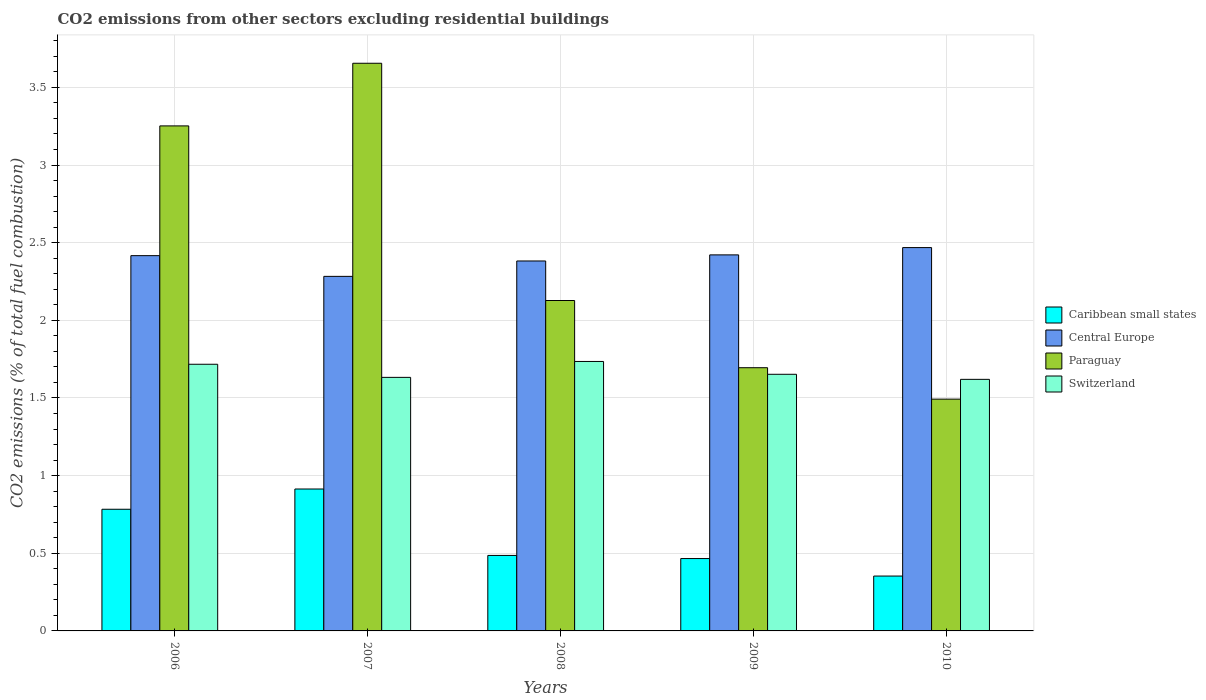Are the number of bars per tick equal to the number of legend labels?
Your answer should be compact. Yes. Are the number of bars on each tick of the X-axis equal?
Give a very brief answer. Yes. How many bars are there on the 2nd tick from the left?
Keep it short and to the point. 4. What is the label of the 4th group of bars from the left?
Your answer should be very brief. 2009. What is the total CO2 emitted in Caribbean small states in 2007?
Your answer should be compact. 0.91. Across all years, what is the maximum total CO2 emitted in Central Europe?
Keep it short and to the point. 2.47. Across all years, what is the minimum total CO2 emitted in Caribbean small states?
Your response must be concise. 0.35. In which year was the total CO2 emitted in Switzerland maximum?
Provide a succinct answer. 2008. What is the total total CO2 emitted in Paraguay in the graph?
Provide a succinct answer. 12.22. What is the difference between the total CO2 emitted in Paraguay in 2006 and that in 2008?
Provide a short and direct response. 1.12. What is the difference between the total CO2 emitted in Caribbean small states in 2010 and the total CO2 emitted in Paraguay in 2006?
Keep it short and to the point. -2.9. What is the average total CO2 emitted in Caribbean small states per year?
Offer a terse response. 0.6. In the year 2008, what is the difference between the total CO2 emitted in Paraguay and total CO2 emitted in Central Europe?
Ensure brevity in your answer.  -0.25. What is the ratio of the total CO2 emitted in Switzerland in 2006 to that in 2008?
Provide a short and direct response. 0.99. Is the difference between the total CO2 emitted in Paraguay in 2006 and 2009 greater than the difference between the total CO2 emitted in Central Europe in 2006 and 2009?
Your answer should be very brief. Yes. What is the difference between the highest and the second highest total CO2 emitted in Caribbean small states?
Make the answer very short. 0.13. What is the difference between the highest and the lowest total CO2 emitted in Switzerland?
Make the answer very short. 0.12. In how many years, is the total CO2 emitted in Caribbean small states greater than the average total CO2 emitted in Caribbean small states taken over all years?
Offer a very short reply. 2. Is the sum of the total CO2 emitted in Caribbean small states in 2009 and 2010 greater than the maximum total CO2 emitted in Central Europe across all years?
Provide a succinct answer. No. Is it the case that in every year, the sum of the total CO2 emitted in Paraguay and total CO2 emitted in Central Europe is greater than the sum of total CO2 emitted in Switzerland and total CO2 emitted in Caribbean small states?
Your response must be concise. No. What does the 1st bar from the left in 2007 represents?
Your answer should be very brief. Caribbean small states. What does the 1st bar from the right in 2008 represents?
Your response must be concise. Switzerland. Is it the case that in every year, the sum of the total CO2 emitted in Switzerland and total CO2 emitted in Paraguay is greater than the total CO2 emitted in Caribbean small states?
Offer a terse response. Yes. Are all the bars in the graph horizontal?
Give a very brief answer. No. Are the values on the major ticks of Y-axis written in scientific E-notation?
Your answer should be compact. No. Does the graph contain any zero values?
Your answer should be very brief. No. Does the graph contain grids?
Your answer should be very brief. Yes. Where does the legend appear in the graph?
Give a very brief answer. Center right. How many legend labels are there?
Offer a terse response. 4. How are the legend labels stacked?
Offer a terse response. Vertical. What is the title of the graph?
Offer a very short reply. CO2 emissions from other sectors excluding residential buildings. What is the label or title of the X-axis?
Make the answer very short. Years. What is the label or title of the Y-axis?
Make the answer very short. CO2 emissions (% of total fuel combustion). What is the CO2 emissions (% of total fuel combustion) in Caribbean small states in 2006?
Make the answer very short. 0.78. What is the CO2 emissions (% of total fuel combustion) in Central Europe in 2006?
Make the answer very short. 2.42. What is the CO2 emissions (% of total fuel combustion) of Paraguay in 2006?
Your answer should be compact. 3.25. What is the CO2 emissions (% of total fuel combustion) of Switzerland in 2006?
Provide a short and direct response. 1.72. What is the CO2 emissions (% of total fuel combustion) in Caribbean small states in 2007?
Provide a succinct answer. 0.91. What is the CO2 emissions (% of total fuel combustion) in Central Europe in 2007?
Provide a succinct answer. 2.28. What is the CO2 emissions (% of total fuel combustion) of Paraguay in 2007?
Provide a short and direct response. 3.66. What is the CO2 emissions (% of total fuel combustion) in Switzerland in 2007?
Keep it short and to the point. 1.63. What is the CO2 emissions (% of total fuel combustion) of Caribbean small states in 2008?
Your response must be concise. 0.49. What is the CO2 emissions (% of total fuel combustion) of Central Europe in 2008?
Offer a terse response. 2.38. What is the CO2 emissions (% of total fuel combustion) in Paraguay in 2008?
Ensure brevity in your answer.  2.13. What is the CO2 emissions (% of total fuel combustion) in Switzerland in 2008?
Give a very brief answer. 1.74. What is the CO2 emissions (% of total fuel combustion) in Caribbean small states in 2009?
Provide a succinct answer. 0.47. What is the CO2 emissions (% of total fuel combustion) of Central Europe in 2009?
Keep it short and to the point. 2.42. What is the CO2 emissions (% of total fuel combustion) in Paraguay in 2009?
Provide a short and direct response. 1.69. What is the CO2 emissions (% of total fuel combustion) of Switzerland in 2009?
Keep it short and to the point. 1.65. What is the CO2 emissions (% of total fuel combustion) in Caribbean small states in 2010?
Give a very brief answer. 0.35. What is the CO2 emissions (% of total fuel combustion) in Central Europe in 2010?
Offer a terse response. 2.47. What is the CO2 emissions (% of total fuel combustion) in Paraguay in 2010?
Give a very brief answer. 1.49. What is the CO2 emissions (% of total fuel combustion) in Switzerland in 2010?
Make the answer very short. 1.62. Across all years, what is the maximum CO2 emissions (% of total fuel combustion) in Caribbean small states?
Offer a very short reply. 0.91. Across all years, what is the maximum CO2 emissions (% of total fuel combustion) in Central Europe?
Your response must be concise. 2.47. Across all years, what is the maximum CO2 emissions (% of total fuel combustion) of Paraguay?
Offer a terse response. 3.66. Across all years, what is the maximum CO2 emissions (% of total fuel combustion) of Switzerland?
Keep it short and to the point. 1.74. Across all years, what is the minimum CO2 emissions (% of total fuel combustion) in Caribbean small states?
Make the answer very short. 0.35. Across all years, what is the minimum CO2 emissions (% of total fuel combustion) in Central Europe?
Offer a terse response. 2.28. Across all years, what is the minimum CO2 emissions (% of total fuel combustion) of Paraguay?
Offer a terse response. 1.49. Across all years, what is the minimum CO2 emissions (% of total fuel combustion) in Switzerland?
Your answer should be compact. 1.62. What is the total CO2 emissions (% of total fuel combustion) in Caribbean small states in the graph?
Offer a very short reply. 3. What is the total CO2 emissions (% of total fuel combustion) of Central Europe in the graph?
Your response must be concise. 11.97. What is the total CO2 emissions (% of total fuel combustion) in Paraguay in the graph?
Your answer should be very brief. 12.22. What is the total CO2 emissions (% of total fuel combustion) of Switzerland in the graph?
Offer a very short reply. 8.36. What is the difference between the CO2 emissions (% of total fuel combustion) of Caribbean small states in 2006 and that in 2007?
Offer a terse response. -0.13. What is the difference between the CO2 emissions (% of total fuel combustion) in Central Europe in 2006 and that in 2007?
Offer a very short reply. 0.13. What is the difference between the CO2 emissions (% of total fuel combustion) in Paraguay in 2006 and that in 2007?
Offer a very short reply. -0.4. What is the difference between the CO2 emissions (% of total fuel combustion) in Switzerland in 2006 and that in 2007?
Offer a terse response. 0.08. What is the difference between the CO2 emissions (% of total fuel combustion) of Caribbean small states in 2006 and that in 2008?
Your answer should be compact. 0.3. What is the difference between the CO2 emissions (% of total fuel combustion) of Central Europe in 2006 and that in 2008?
Provide a succinct answer. 0.03. What is the difference between the CO2 emissions (% of total fuel combustion) of Paraguay in 2006 and that in 2008?
Your answer should be very brief. 1.12. What is the difference between the CO2 emissions (% of total fuel combustion) of Switzerland in 2006 and that in 2008?
Your answer should be compact. -0.02. What is the difference between the CO2 emissions (% of total fuel combustion) of Caribbean small states in 2006 and that in 2009?
Your answer should be compact. 0.32. What is the difference between the CO2 emissions (% of total fuel combustion) of Central Europe in 2006 and that in 2009?
Give a very brief answer. -0. What is the difference between the CO2 emissions (% of total fuel combustion) of Paraguay in 2006 and that in 2009?
Provide a succinct answer. 1.56. What is the difference between the CO2 emissions (% of total fuel combustion) of Switzerland in 2006 and that in 2009?
Give a very brief answer. 0.06. What is the difference between the CO2 emissions (% of total fuel combustion) in Caribbean small states in 2006 and that in 2010?
Your response must be concise. 0.43. What is the difference between the CO2 emissions (% of total fuel combustion) in Central Europe in 2006 and that in 2010?
Your answer should be compact. -0.05. What is the difference between the CO2 emissions (% of total fuel combustion) in Paraguay in 2006 and that in 2010?
Ensure brevity in your answer.  1.76. What is the difference between the CO2 emissions (% of total fuel combustion) in Switzerland in 2006 and that in 2010?
Your answer should be very brief. 0.1. What is the difference between the CO2 emissions (% of total fuel combustion) in Caribbean small states in 2007 and that in 2008?
Your answer should be very brief. 0.43. What is the difference between the CO2 emissions (% of total fuel combustion) in Central Europe in 2007 and that in 2008?
Offer a very short reply. -0.1. What is the difference between the CO2 emissions (% of total fuel combustion) in Paraguay in 2007 and that in 2008?
Provide a succinct answer. 1.53. What is the difference between the CO2 emissions (% of total fuel combustion) in Switzerland in 2007 and that in 2008?
Make the answer very short. -0.1. What is the difference between the CO2 emissions (% of total fuel combustion) in Caribbean small states in 2007 and that in 2009?
Your answer should be compact. 0.45. What is the difference between the CO2 emissions (% of total fuel combustion) of Central Europe in 2007 and that in 2009?
Offer a terse response. -0.14. What is the difference between the CO2 emissions (% of total fuel combustion) of Paraguay in 2007 and that in 2009?
Ensure brevity in your answer.  1.96. What is the difference between the CO2 emissions (% of total fuel combustion) of Switzerland in 2007 and that in 2009?
Your answer should be compact. -0.02. What is the difference between the CO2 emissions (% of total fuel combustion) in Caribbean small states in 2007 and that in 2010?
Your answer should be compact. 0.56. What is the difference between the CO2 emissions (% of total fuel combustion) of Central Europe in 2007 and that in 2010?
Your response must be concise. -0.19. What is the difference between the CO2 emissions (% of total fuel combustion) in Paraguay in 2007 and that in 2010?
Your answer should be very brief. 2.16. What is the difference between the CO2 emissions (% of total fuel combustion) in Switzerland in 2007 and that in 2010?
Make the answer very short. 0.01. What is the difference between the CO2 emissions (% of total fuel combustion) in Caribbean small states in 2008 and that in 2009?
Give a very brief answer. 0.02. What is the difference between the CO2 emissions (% of total fuel combustion) of Central Europe in 2008 and that in 2009?
Give a very brief answer. -0.04. What is the difference between the CO2 emissions (% of total fuel combustion) in Paraguay in 2008 and that in 2009?
Ensure brevity in your answer.  0.43. What is the difference between the CO2 emissions (% of total fuel combustion) in Switzerland in 2008 and that in 2009?
Give a very brief answer. 0.08. What is the difference between the CO2 emissions (% of total fuel combustion) in Caribbean small states in 2008 and that in 2010?
Make the answer very short. 0.13. What is the difference between the CO2 emissions (% of total fuel combustion) in Central Europe in 2008 and that in 2010?
Give a very brief answer. -0.09. What is the difference between the CO2 emissions (% of total fuel combustion) in Paraguay in 2008 and that in 2010?
Your answer should be very brief. 0.64. What is the difference between the CO2 emissions (% of total fuel combustion) of Switzerland in 2008 and that in 2010?
Ensure brevity in your answer.  0.12. What is the difference between the CO2 emissions (% of total fuel combustion) of Caribbean small states in 2009 and that in 2010?
Your answer should be compact. 0.11. What is the difference between the CO2 emissions (% of total fuel combustion) in Central Europe in 2009 and that in 2010?
Provide a succinct answer. -0.05. What is the difference between the CO2 emissions (% of total fuel combustion) in Paraguay in 2009 and that in 2010?
Offer a very short reply. 0.2. What is the difference between the CO2 emissions (% of total fuel combustion) in Switzerland in 2009 and that in 2010?
Your response must be concise. 0.03. What is the difference between the CO2 emissions (% of total fuel combustion) in Caribbean small states in 2006 and the CO2 emissions (% of total fuel combustion) in Central Europe in 2007?
Provide a short and direct response. -1.5. What is the difference between the CO2 emissions (% of total fuel combustion) of Caribbean small states in 2006 and the CO2 emissions (% of total fuel combustion) of Paraguay in 2007?
Your answer should be very brief. -2.87. What is the difference between the CO2 emissions (% of total fuel combustion) in Caribbean small states in 2006 and the CO2 emissions (% of total fuel combustion) in Switzerland in 2007?
Give a very brief answer. -0.85. What is the difference between the CO2 emissions (% of total fuel combustion) in Central Europe in 2006 and the CO2 emissions (% of total fuel combustion) in Paraguay in 2007?
Ensure brevity in your answer.  -1.24. What is the difference between the CO2 emissions (% of total fuel combustion) in Central Europe in 2006 and the CO2 emissions (% of total fuel combustion) in Switzerland in 2007?
Provide a succinct answer. 0.78. What is the difference between the CO2 emissions (% of total fuel combustion) in Paraguay in 2006 and the CO2 emissions (% of total fuel combustion) in Switzerland in 2007?
Ensure brevity in your answer.  1.62. What is the difference between the CO2 emissions (% of total fuel combustion) in Caribbean small states in 2006 and the CO2 emissions (% of total fuel combustion) in Central Europe in 2008?
Your answer should be compact. -1.6. What is the difference between the CO2 emissions (% of total fuel combustion) of Caribbean small states in 2006 and the CO2 emissions (% of total fuel combustion) of Paraguay in 2008?
Offer a terse response. -1.34. What is the difference between the CO2 emissions (% of total fuel combustion) in Caribbean small states in 2006 and the CO2 emissions (% of total fuel combustion) in Switzerland in 2008?
Your answer should be very brief. -0.95. What is the difference between the CO2 emissions (% of total fuel combustion) of Central Europe in 2006 and the CO2 emissions (% of total fuel combustion) of Paraguay in 2008?
Offer a very short reply. 0.29. What is the difference between the CO2 emissions (% of total fuel combustion) in Central Europe in 2006 and the CO2 emissions (% of total fuel combustion) in Switzerland in 2008?
Your answer should be compact. 0.68. What is the difference between the CO2 emissions (% of total fuel combustion) in Paraguay in 2006 and the CO2 emissions (% of total fuel combustion) in Switzerland in 2008?
Provide a short and direct response. 1.52. What is the difference between the CO2 emissions (% of total fuel combustion) of Caribbean small states in 2006 and the CO2 emissions (% of total fuel combustion) of Central Europe in 2009?
Your response must be concise. -1.64. What is the difference between the CO2 emissions (% of total fuel combustion) in Caribbean small states in 2006 and the CO2 emissions (% of total fuel combustion) in Paraguay in 2009?
Give a very brief answer. -0.91. What is the difference between the CO2 emissions (% of total fuel combustion) of Caribbean small states in 2006 and the CO2 emissions (% of total fuel combustion) of Switzerland in 2009?
Ensure brevity in your answer.  -0.87. What is the difference between the CO2 emissions (% of total fuel combustion) in Central Europe in 2006 and the CO2 emissions (% of total fuel combustion) in Paraguay in 2009?
Your response must be concise. 0.72. What is the difference between the CO2 emissions (% of total fuel combustion) in Central Europe in 2006 and the CO2 emissions (% of total fuel combustion) in Switzerland in 2009?
Your answer should be very brief. 0.76. What is the difference between the CO2 emissions (% of total fuel combustion) of Paraguay in 2006 and the CO2 emissions (% of total fuel combustion) of Switzerland in 2009?
Keep it short and to the point. 1.6. What is the difference between the CO2 emissions (% of total fuel combustion) in Caribbean small states in 2006 and the CO2 emissions (% of total fuel combustion) in Central Europe in 2010?
Your answer should be very brief. -1.68. What is the difference between the CO2 emissions (% of total fuel combustion) of Caribbean small states in 2006 and the CO2 emissions (% of total fuel combustion) of Paraguay in 2010?
Ensure brevity in your answer.  -0.71. What is the difference between the CO2 emissions (% of total fuel combustion) of Caribbean small states in 2006 and the CO2 emissions (% of total fuel combustion) of Switzerland in 2010?
Offer a very short reply. -0.84. What is the difference between the CO2 emissions (% of total fuel combustion) of Central Europe in 2006 and the CO2 emissions (% of total fuel combustion) of Paraguay in 2010?
Give a very brief answer. 0.92. What is the difference between the CO2 emissions (% of total fuel combustion) in Central Europe in 2006 and the CO2 emissions (% of total fuel combustion) in Switzerland in 2010?
Make the answer very short. 0.8. What is the difference between the CO2 emissions (% of total fuel combustion) of Paraguay in 2006 and the CO2 emissions (% of total fuel combustion) of Switzerland in 2010?
Make the answer very short. 1.63. What is the difference between the CO2 emissions (% of total fuel combustion) of Caribbean small states in 2007 and the CO2 emissions (% of total fuel combustion) of Central Europe in 2008?
Keep it short and to the point. -1.47. What is the difference between the CO2 emissions (% of total fuel combustion) in Caribbean small states in 2007 and the CO2 emissions (% of total fuel combustion) in Paraguay in 2008?
Offer a very short reply. -1.21. What is the difference between the CO2 emissions (% of total fuel combustion) in Caribbean small states in 2007 and the CO2 emissions (% of total fuel combustion) in Switzerland in 2008?
Provide a short and direct response. -0.82. What is the difference between the CO2 emissions (% of total fuel combustion) of Central Europe in 2007 and the CO2 emissions (% of total fuel combustion) of Paraguay in 2008?
Provide a short and direct response. 0.16. What is the difference between the CO2 emissions (% of total fuel combustion) of Central Europe in 2007 and the CO2 emissions (% of total fuel combustion) of Switzerland in 2008?
Provide a short and direct response. 0.55. What is the difference between the CO2 emissions (% of total fuel combustion) in Paraguay in 2007 and the CO2 emissions (% of total fuel combustion) in Switzerland in 2008?
Your answer should be very brief. 1.92. What is the difference between the CO2 emissions (% of total fuel combustion) in Caribbean small states in 2007 and the CO2 emissions (% of total fuel combustion) in Central Europe in 2009?
Provide a succinct answer. -1.51. What is the difference between the CO2 emissions (% of total fuel combustion) in Caribbean small states in 2007 and the CO2 emissions (% of total fuel combustion) in Paraguay in 2009?
Provide a short and direct response. -0.78. What is the difference between the CO2 emissions (% of total fuel combustion) of Caribbean small states in 2007 and the CO2 emissions (% of total fuel combustion) of Switzerland in 2009?
Provide a succinct answer. -0.74. What is the difference between the CO2 emissions (% of total fuel combustion) of Central Europe in 2007 and the CO2 emissions (% of total fuel combustion) of Paraguay in 2009?
Offer a terse response. 0.59. What is the difference between the CO2 emissions (% of total fuel combustion) in Central Europe in 2007 and the CO2 emissions (% of total fuel combustion) in Switzerland in 2009?
Your answer should be compact. 0.63. What is the difference between the CO2 emissions (% of total fuel combustion) in Paraguay in 2007 and the CO2 emissions (% of total fuel combustion) in Switzerland in 2009?
Offer a very short reply. 2. What is the difference between the CO2 emissions (% of total fuel combustion) of Caribbean small states in 2007 and the CO2 emissions (% of total fuel combustion) of Central Europe in 2010?
Your answer should be very brief. -1.55. What is the difference between the CO2 emissions (% of total fuel combustion) of Caribbean small states in 2007 and the CO2 emissions (% of total fuel combustion) of Paraguay in 2010?
Keep it short and to the point. -0.58. What is the difference between the CO2 emissions (% of total fuel combustion) of Caribbean small states in 2007 and the CO2 emissions (% of total fuel combustion) of Switzerland in 2010?
Make the answer very short. -0.71. What is the difference between the CO2 emissions (% of total fuel combustion) of Central Europe in 2007 and the CO2 emissions (% of total fuel combustion) of Paraguay in 2010?
Keep it short and to the point. 0.79. What is the difference between the CO2 emissions (% of total fuel combustion) in Central Europe in 2007 and the CO2 emissions (% of total fuel combustion) in Switzerland in 2010?
Your answer should be very brief. 0.66. What is the difference between the CO2 emissions (% of total fuel combustion) in Paraguay in 2007 and the CO2 emissions (% of total fuel combustion) in Switzerland in 2010?
Keep it short and to the point. 2.04. What is the difference between the CO2 emissions (% of total fuel combustion) of Caribbean small states in 2008 and the CO2 emissions (% of total fuel combustion) of Central Europe in 2009?
Offer a very short reply. -1.94. What is the difference between the CO2 emissions (% of total fuel combustion) in Caribbean small states in 2008 and the CO2 emissions (% of total fuel combustion) in Paraguay in 2009?
Give a very brief answer. -1.21. What is the difference between the CO2 emissions (% of total fuel combustion) in Caribbean small states in 2008 and the CO2 emissions (% of total fuel combustion) in Switzerland in 2009?
Offer a terse response. -1.17. What is the difference between the CO2 emissions (% of total fuel combustion) of Central Europe in 2008 and the CO2 emissions (% of total fuel combustion) of Paraguay in 2009?
Provide a succinct answer. 0.69. What is the difference between the CO2 emissions (% of total fuel combustion) in Central Europe in 2008 and the CO2 emissions (% of total fuel combustion) in Switzerland in 2009?
Ensure brevity in your answer.  0.73. What is the difference between the CO2 emissions (% of total fuel combustion) of Paraguay in 2008 and the CO2 emissions (% of total fuel combustion) of Switzerland in 2009?
Your answer should be very brief. 0.48. What is the difference between the CO2 emissions (% of total fuel combustion) in Caribbean small states in 2008 and the CO2 emissions (% of total fuel combustion) in Central Europe in 2010?
Ensure brevity in your answer.  -1.98. What is the difference between the CO2 emissions (% of total fuel combustion) in Caribbean small states in 2008 and the CO2 emissions (% of total fuel combustion) in Paraguay in 2010?
Make the answer very short. -1.01. What is the difference between the CO2 emissions (% of total fuel combustion) in Caribbean small states in 2008 and the CO2 emissions (% of total fuel combustion) in Switzerland in 2010?
Keep it short and to the point. -1.13. What is the difference between the CO2 emissions (% of total fuel combustion) in Central Europe in 2008 and the CO2 emissions (% of total fuel combustion) in Paraguay in 2010?
Your answer should be very brief. 0.89. What is the difference between the CO2 emissions (% of total fuel combustion) of Central Europe in 2008 and the CO2 emissions (% of total fuel combustion) of Switzerland in 2010?
Make the answer very short. 0.76. What is the difference between the CO2 emissions (% of total fuel combustion) in Paraguay in 2008 and the CO2 emissions (% of total fuel combustion) in Switzerland in 2010?
Offer a terse response. 0.51. What is the difference between the CO2 emissions (% of total fuel combustion) in Caribbean small states in 2009 and the CO2 emissions (% of total fuel combustion) in Central Europe in 2010?
Your response must be concise. -2. What is the difference between the CO2 emissions (% of total fuel combustion) of Caribbean small states in 2009 and the CO2 emissions (% of total fuel combustion) of Paraguay in 2010?
Your answer should be compact. -1.03. What is the difference between the CO2 emissions (% of total fuel combustion) of Caribbean small states in 2009 and the CO2 emissions (% of total fuel combustion) of Switzerland in 2010?
Keep it short and to the point. -1.15. What is the difference between the CO2 emissions (% of total fuel combustion) in Central Europe in 2009 and the CO2 emissions (% of total fuel combustion) in Paraguay in 2010?
Provide a succinct answer. 0.93. What is the difference between the CO2 emissions (% of total fuel combustion) in Central Europe in 2009 and the CO2 emissions (% of total fuel combustion) in Switzerland in 2010?
Offer a very short reply. 0.8. What is the difference between the CO2 emissions (% of total fuel combustion) of Paraguay in 2009 and the CO2 emissions (% of total fuel combustion) of Switzerland in 2010?
Offer a very short reply. 0.07. What is the average CO2 emissions (% of total fuel combustion) in Caribbean small states per year?
Give a very brief answer. 0.6. What is the average CO2 emissions (% of total fuel combustion) of Central Europe per year?
Your answer should be very brief. 2.39. What is the average CO2 emissions (% of total fuel combustion) of Paraguay per year?
Offer a terse response. 2.44. What is the average CO2 emissions (% of total fuel combustion) in Switzerland per year?
Provide a succinct answer. 1.67. In the year 2006, what is the difference between the CO2 emissions (% of total fuel combustion) of Caribbean small states and CO2 emissions (% of total fuel combustion) of Central Europe?
Give a very brief answer. -1.63. In the year 2006, what is the difference between the CO2 emissions (% of total fuel combustion) in Caribbean small states and CO2 emissions (% of total fuel combustion) in Paraguay?
Your answer should be very brief. -2.47. In the year 2006, what is the difference between the CO2 emissions (% of total fuel combustion) of Caribbean small states and CO2 emissions (% of total fuel combustion) of Switzerland?
Provide a short and direct response. -0.93. In the year 2006, what is the difference between the CO2 emissions (% of total fuel combustion) of Central Europe and CO2 emissions (% of total fuel combustion) of Paraguay?
Your answer should be compact. -0.84. In the year 2006, what is the difference between the CO2 emissions (% of total fuel combustion) in Central Europe and CO2 emissions (% of total fuel combustion) in Switzerland?
Provide a short and direct response. 0.7. In the year 2006, what is the difference between the CO2 emissions (% of total fuel combustion) in Paraguay and CO2 emissions (% of total fuel combustion) in Switzerland?
Your answer should be very brief. 1.53. In the year 2007, what is the difference between the CO2 emissions (% of total fuel combustion) of Caribbean small states and CO2 emissions (% of total fuel combustion) of Central Europe?
Ensure brevity in your answer.  -1.37. In the year 2007, what is the difference between the CO2 emissions (% of total fuel combustion) of Caribbean small states and CO2 emissions (% of total fuel combustion) of Paraguay?
Give a very brief answer. -2.74. In the year 2007, what is the difference between the CO2 emissions (% of total fuel combustion) in Caribbean small states and CO2 emissions (% of total fuel combustion) in Switzerland?
Your answer should be very brief. -0.72. In the year 2007, what is the difference between the CO2 emissions (% of total fuel combustion) in Central Europe and CO2 emissions (% of total fuel combustion) in Paraguay?
Provide a succinct answer. -1.37. In the year 2007, what is the difference between the CO2 emissions (% of total fuel combustion) in Central Europe and CO2 emissions (% of total fuel combustion) in Switzerland?
Offer a very short reply. 0.65. In the year 2007, what is the difference between the CO2 emissions (% of total fuel combustion) of Paraguay and CO2 emissions (% of total fuel combustion) of Switzerland?
Offer a very short reply. 2.02. In the year 2008, what is the difference between the CO2 emissions (% of total fuel combustion) of Caribbean small states and CO2 emissions (% of total fuel combustion) of Central Europe?
Provide a short and direct response. -1.9. In the year 2008, what is the difference between the CO2 emissions (% of total fuel combustion) in Caribbean small states and CO2 emissions (% of total fuel combustion) in Paraguay?
Keep it short and to the point. -1.64. In the year 2008, what is the difference between the CO2 emissions (% of total fuel combustion) in Caribbean small states and CO2 emissions (% of total fuel combustion) in Switzerland?
Offer a very short reply. -1.25. In the year 2008, what is the difference between the CO2 emissions (% of total fuel combustion) in Central Europe and CO2 emissions (% of total fuel combustion) in Paraguay?
Provide a succinct answer. 0.25. In the year 2008, what is the difference between the CO2 emissions (% of total fuel combustion) in Central Europe and CO2 emissions (% of total fuel combustion) in Switzerland?
Ensure brevity in your answer.  0.65. In the year 2008, what is the difference between the CO2 emissions (% of total fuel combustion) of Paraguay and CO2 emissions (% of total fuel combustion) of Switzerland?
Ensure brevity in your answer.  0.39. In the year 2009, what is the difference between the CO2 emissions (% of total fuel combustion) of Caribbean small states and CO2 emissions (% of total fuel combustion) of Central Europe?
Make the answer very short. -1.96. In the year 2009, what is the difference between the CO2 emissions (% of total fuel combustion) in Caribbean small states and CO2 emissions (% of total fuel combustion) in Paraguay?
Your answer should be compact. -1.23. In the year 2009, what is the difference between the CO2 emissions (% of total fuel combustion) in Caribbean small states and CO2 emissions (% of total fuel combustion) in Switzerland?
Provide a short and direct response. -1.19. In the year 2009, what is the difference between the CO2 emissions (% of total fuel combustion) in Central Europe and CO2 emissions (% of total fuel combustion) in Paraguay?
Your answer should be very brief. 0.73. In the year 2009, what is the difference between the CO2 emissions (% of total fuel combustion) of Central Europe and CO2 emissions (% of total fuel combustion) of Switzerland?
Offer a very short reply. 0.77. In the year 2009, what is the difference between the CO2 emissions (% of total fuel combustion) of Paraguay and CO2 emissions (% of total fuel combustion) of Switzerland?
Make the answer very short. 0.04. In the year 2010, what is the difference between the CO2 emissions (% of total fuel combustion) in Caribbean small states and CO2 emissions (% of total fuel combustion) in Central Europe?
Your answer should be very brief. -2.12. In the year 2010, what is the difference between the CO2 emissions (% of total fuel combustion) of Caribbean small states and CO2 emissions (% of total fuel combustion) of Paraguay?
Offer a terse response. -1.14. In the year 2010, what is the difference between the CO2 emissions (% of total fuel combustion) in Caribbean small states and CO2 emissions (% of total fuel combustion) in Switzerland?
Your response must be concise. -1.27. In the year 2010, what is the difference between the CO2 emissions (% of total fuel combustion) of Central Europe and CO2 emissions (% of total fuel combustion) of Paraguay?
Offer a terse response. 0.98. In the year 2010, what is the difference between the CO2 emissions (% of total fuel combustion) in Central Europe and CO2 emissions (% of total fuel combustion) in Switzerland?
Ensure brevity in your answer.  0.85. In the year 2010, what is the difference between the CO2 emissions (% of total fuel combustion) in Paraguay and CO2 emissions (% of total fuel combustion) in Switzerland?
Give a very brief answer. -0.13. What is the ratio of the CO2 emissions (% of total fuel combustion) in Caribbean small states in 2006 to that in 2007?
Provide a succinct answer. 0.86. What is the ratio of the CO2 emissions (% of total fuel combustion) of Central Europe in 2006 to that in 2007?
Provide a short and direct response. 1.06. What is the ratio of the CO2 emissions (% of total fuel combustion) in Paraguay in 2006 to that in 2007?
Make the answer very short. 0.89. What is the ratio of the CO2 emissions (% of total fuel combustion) of Switzerland in 2006 to that in 2007?
Your answer should be compact. 1.05. What is the ratio of the CO2 emissions (% of total fuel combustion) in Caribbean small states in 2006 to that in 2008?
Offer a terse response. 1.61. What is the ratio of the CO2 emissions (% of total fuel combustion) in Central Europe in 2006 to that in 2008?
Your answer should be very brief. 1.01. What is the ratio of the CO2 emissions (% of total fuel combustion) in Paraguay in 2006 to that in 2008?
Make the answer very short. 1.53. What is the ratio of the CO2 emissions (% of total fuel combustion) of Switzerland in 2006 to that in 2008?
Provide a succinct answer. 0.99. What is the ratio of the CO2 emissions (% of total fuel combustion) of Caribbean small states in 2006 to that in 2009?
Your response must be concise. 1.68. What is the ratio of the CO2 emissions (% of total fuel combustion) in Central Europe in 2006 to that in 2009?
Your response must be concise. 1. What is the ratio of the CO2 emissions (% of total fuel combustion) in Paraguay in 2006 to that in 2009?
Make the answer very short. 1.92. What is the ratio of the CO2 emissions (% of total fuel combustion) in Switzerland in 2006 to that in 2009?
Provide a short and direct response. 1.04. What is the ratio of the CO2 emissions (% of total fuel combustion) of Caribbean small states in 2006 to that in 2010?
Ensure brevity in your answer.  2.22. What is the ratio of the CO2 emissions (% of total fuel combustion) of Paraguay in 2006 to that in 2010?
Provide a short and direct response. 2.18. What is the ratio of the CO2 emissions (% of total fuel combustion) in Switzerland in 2006 to that in 2010?
Provide a short and direct response. 1.06. What is the ratio of the CO2 emissions (% of total fuel combustion) of Caribbean small states in 2007 to that in 2008?
Provide a short and direct response. 1.88. What is the ratio of the CO2 emissions (% of total fuel combustion) of Central Europe in 2007 to that in 2008?
Provide a succinct answer. 0.96. What is the ratio of the CO2 emissions (% of total fuel combustion) in Paraguay in 2007 to that in 2008?
Give a very brief answer. 1.72. What is the ratio of the CO2 emissions (% of total fuel combustion) of Switzerland in 2007 to that in 2008?
Ensure brevity in your answer.  0.94. What is the ratio of the CO2 emissions (% of total fuel combustion) of Caribbean small states in 2007 to that in 2009?
Give a very brief answer. 1.96. What is the ratio of the CO2 emissions (% of total fuel combustion) of Central Europe in 2007 to that in 2009?
Keep it short and to the point. 0.94. What is the ratio of the CO2 emissions (% of total fuel combustion) of Paraguay in 2007 to that in 2009?
Your answer should be compact. 2.16. What is the ratio of the CO2 emissions (% of total fuel combustion) of Caribbean small states in 2007 to that in 2010?
Offer a terse response. 2.59. What is the ratio of the CO2 emissions (% of total fuel combustion) of Central Europe in 2007 to that in 2010?
Your response must be concise. 0.92. What is the ratio of the CO2 emissions (% of total fuel combustion) of Paraguay in 2007 to that in 2010?
Ensure brevity in your answer.  2.45. What is the ratio of the CO2 emissions (% of total fuel combustion) in Switzerland in 2007 to that in 2010?
Your answer should be compact. 1.01. What is the ratio of the CO2 emissions (% of total fuel combustion) of Caribbean small states in 2008 to that in 2009?
Offer a terse response. 1.04. What is the ratio of the CO2 emissions (% of total fuel combustion) in Central Europe in 2008 to that in 2009?
Your answer should be very brief. 0.98. What is the ratio of the CO2 emissions (% of total fuel combustion) in Paraguay in 2008 to that in 2009?
Your answer should be compact. 1.26. What is the ratio of the CO2 emissions (% of total fuel combustion) in Caribbean small states in 2008 to that in 2010?
Your answer should be very brief. 1.38. What is the ratio of the CO2 emissions (% of total fuel combustion) in Central Europe in 2008 to that in 2010?
Your response must be concise. 0.97. What is the ratio of the CO2 emissions (% of total fuel combustion) of Paraguay in 2008 to that in 2010?
Give a very brief answer. 1.43. What is the ratio of the CO2 emissions (% of total fuel combustion) in Switzerland in 2008 to that in 2010?
Provide a succinct answer. 1.07. What is the ratio of the CO2 emissions (% of total fuel combustion) in Caribbean small states in 2009 to that in 2010?
Make the answer very short. 1.32. What is the ratio of the CO2 emissions (% of total fuel combustion) of Central Europe in 2009 to that in 2010?
Give a very brief answer. 0.98. What is the ratio of the CO2 emissions (% of total fuel combustion) of Paraguay in 2009 to that in 2010?
Your answer should be very brief. 1.14. What is the ratio of the CO2 emissions (% of total fuel combustion) in Switzerland in 2009 to that in 2010?
Make the answer very short. 1.02. What is the difference between the highest and the second highest CO2 emissions (% of total fuel combustion) in Caribbean small states?
Offer a very short reply. 0.13. What is the difference between the highest and the second highest CO2 emissions (% of total fuel combustion) of Central Europe?
Offer a very short reply. 0.05. What is the difference between the highest and the second highest CO2 emissions (% of total fuel combustion) of Paraguay?
Make the answer very short. 0.4. What is the difference between the highest and the second highest CO2 emissions (% of total fuel combustion) of Switzerland?
Provide a succinct answer. 0.02. What is the difference between the highest and the lowest CO2 emissions (% of total fuel combustion) in Caribbean small states?
Your answer should be compact. 0.56. What is the difference between the highest and the lowest CO2 emissions (% of total fuel combustion) in Central Europe?
Provide a succinct answer. 0.19. What is the difference between the highest and the lowest CO2 emissions (% of total fuel combustion) in Paraguay?
Ensure brevity in your answer.  2.16. What is the difference between the highest and the lowest CO2 emissions (% of total fuel combustion) in Switzerland?
Your response must be concise. 0.12. 